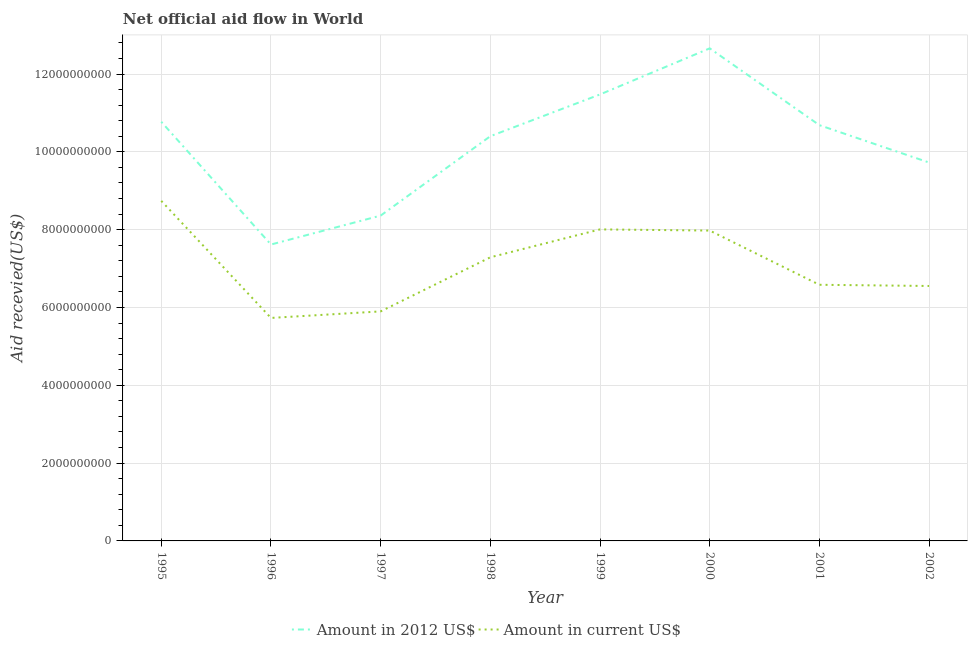How many different coloured lines are there?
Your answer should be compact. 2. Is the number of lines equal to the number of legend labels?
Provide a succinct answer. Yes. What is the amount of aid received(expressed in 2012 us$) in 2002?
Your answer should be very brief. 9.73e+09. Across all years, what is the maximum amount of aid received(expressed in us$)?
Make the answer very short. 8.74e+09. Across all years, what is the minimum amount of aid received(expressed in us$)?
Provide a short and direct response. 5.73e+09. In which year was the amount of aid received(expressed in us$) maximum?
Offer a very short reply. 1995. In which year was the amount of aid received(expressed in 2012 us$) minimum?
Provide a succinct answer. 1996. What is the total amount of aid received(expressed in 2012 us$) in the graph?
Make the answer very short. 8.17e+1. What is the difference between the amount of aid received(expressed in us$) in 1997 and that in 2001?
Provide a succinct answer. -6.84e+08. What is the difference between the amount of aid received(expressed in us$) in 2000 and the amount of aid received(expressed in 2012 us$) in 1996?
Offer a very short reply. 3.59e+08. What is the average amount of aid received(expressed in us$) per year?
Offer a very short reply. 7.10e+09. In the year 1995, what is the difference between the amount of aid received(expressed in us$) and amount of aid received(expressed in 2012 us$)?
Make the answer very short. -2.03e+09. What is the ratio of the amount of aid received(expressed in us$) in 1997 to that in 1998?
Ensure brevity in your answer.  0.81. Is the difference between the amount of aid received(expressed in us$) in 2000 and 2002 greater than the difference between the amount of aid received(expressed in 2012 us$) in 2000 and 2002?
Your answer should be compact. No. What is the difference between the highest and the second highest amount of aid received(expressed in 2012 us$)?
Your answer should be compact. 1.18e+09. What is the difference between the highest and the lowest amount of aid received(expressed in 2012 us$)?
Ensure brevity in your answer.  5.04e+09. In how many years, is the amount of aid received(expressed in us$) greater than the average amount of aid received(expressed in us$) taken over all years?
Your answer should be compact. 4. Does the amount of aid received(expressed in us$) monotonically increase over the years?
Give a very brief answer. No. Is the amount of aid received(expressed in us$) strictly less than the amount of aid received(expressed in 2012 us$) over the years?
Offer a terse response. Yes. What is the difference between two consecutive major ticks on the Y-axis?
Your answer should be compact. 2.00e+09. Are the values on the major ticks of Y-axis written in scientific E-notation?
Your answer should be very brief. No. Where does the legend appear in the graph?
Your response must be concise. Bottom center. How many legend labels are there?
Give a very brief answer. 2. What is the title of the graph?
Keep it short and to the point. Net official aid flow in World. Does "Nitrous oxide emissions" appear as one of the legend labels in the graph?
Offer a terse response. No. What is the label or title of the X-axis?
Keep it short and to the point. Year. What is the label or title of the Y-axis?
Ensure brevity in your answer.  Aid recevied(US$). What is the Aid recevied(US$) in Amount in 2012 US$ in 1995?
Provide a succinct answer. 1.08e+1. What is the Aid recevied(US$) of Amount in current US$ in 1995?
Provide a short and direct response. 8.74e+09. What is the Aid recevied(US$) of Amount in 2012 US$ in 1996?
Your answer should be compact. 7.62e+09. What is the Aid recevied(US$) in Amount in current US$ in 1996?
Your response must be concise. 5.73e+09. What is the Aid recevied(US$) of Amount in 2012 US$ in 1997?
Your answer should be very brief. 8.36e+09. What is the Aid recevied(US$) of Amount in current US$ in 1997?
Make the answer very short. 5.90e+09. What is the Aid recevied(US$) of Amount in 2012 US$ in 1998?
Give a very brief answer. 1.04e+1. What is the Aid recevied(US$) of Amount in current US$ in 1998?
Provide a short and direct response. 7.29e+09. What is the Aid recevied(US$) in Amount in 2012 US$ in 1999?
Your answer should be compact. 1.15e+1. What is the Aid recevied(US$) of Amount in current US$ in 1999?
Give a very brief answer. 8.01e+09. What is the Aid recevied(US$) of Amount in 2012 US$ in 2000?
Make the answer very short. 1.27e+1. What is the Aid recevied(US$) of Amount in current US$ in 2000?
Make the answer very short. 7.98e+09. What is the Aid recevied(US$) of Amount in 2012 US$ in 2001?
Your response must be concise. 1.07e+1. What is the Aid recevied(US$) of Amount in current US$ in 2001?
Provide a short and direct response. 6.58e+09. What is the Aid recevied(US$) in Amount in 2012 US$ in 2002?
Ensure brevity in your answer.  9.73e+09. What is the Aid recevied(US$) of Amount in current US$ in 2002?
Make the answer very short. 6.55e+09. Across all years, what is the maximum Aid recevied(US$) of Amount in 2012 US$?
Keep it short and to the point. 1.27e+1. Across all years, what is the maximum Aid recevied(US$) in Amount in current US$?
Keep it short and to the point. 8.74e+09. Across all years, what is the minimum Aid recevied(US$) of Amount in 2012 US$?
Your answer should be compact. 7.62e+09. Across all years, what is the minimum Aid recevied(US$) in Amount in current US$?
Provide a short and direct response. 5.73e+09. What is the total Aid recevied(US$) of Amount in 2012 US$ in the graph?
Your answer should be compact. 8.17e+1. What is the total Aid recevied(US$) in Amount in current US$ in the graph?
Keep it short and to the point. 5.68e+1. What is the difference between the Aid recevied(US$) in Amount in 2012 US$ in 1995 and that in 1996?
Your answer should be very brief. 3.16e+09. What is the difference between the Aid recevied(US$) of Amount in current US$ in 1995 and that in 1996?
Offer a very short reply. 3.01e+09. What is the difference between the Aid recevied(US$) of Amount in 2012 US$ in 1995 and that in 1997?
Offer a terse response. 2.41e+09. What is the difference between the Aid recevied(US$) in Amount in current US$ in 1995 and that in 1997?
Offer a terse response. 2.84e+09. What is the difference between the Aid recevied(US$) of Amount in 2012 US$ in 1995 and that in 1998?
Offer a very short reply. 3.71e+08. What is the difference between the Aid recevied(US$) in Amount in current US$ in 1995 and that in 1998?
Your answer should be very brief. 1.45e+09. What is the difference between the Aid recevied(US$) of Amount in 2012 US$ in 1995 and that in 1999?
Offer a very short reply. -7.02e+08. What is the difference between the Aid recevied(US$) in Amount in current US$ in 1995 and that in 1999?
Provide a succinct answer. 7.33e+08. What is the difference between the Aid recevied(US$) in Amount in 2012 US$ in 1995 and that in 2000?
Ensure brevity in your answer.  -1.89e+09. What is the difference between the Aid recevied(US$) of Amount in current US$ in 1995 and that in 2000?
Provide a succinct answer. 7.63e+08. What is the difference between the Aid recevied(US$) in Amount in 2012 US$ in 1995 and that in 2001?
Keep it short and to the point. 8.75e+07. What is the difference between the Aid recevied(US$) in Amount in current US$ in 1995 and that in 2001?
Ensure brevity in your answer.  2.16e+09. What is the difference between the Aid recevied(US$) of Amount in 2012 US$ in 1995 and that in 2002?
Your answer should be compact. 1.05e+09. What is the difference between the Aid recevied(US$) in Amount in current US$ in 1995 and that in 2002?
Your answer should be compact. 2.19e+09. What is the difference between the Aid recevied(US$) in Amount in 2012 US$ in 1996 and that in 1997?
Offer a terse response. -7.43e+08. What is the difference between the Aid recevied(US$) in Amount in current US$ in 1996 and that in 1997?
Your answer should be very brief. -1.68e+08. What is the difference between the Aid recevied(US$) in Amount in 2012 US$ in 1996 and that in 1998?
Provide a succinct answer. -2.78e+09. What is the difference between the Aid recevied(US$) of Amount in current US$ in 1996 and that in 1998?
Your answer should be compact. -1.56e+09. What is the difference between the Aid recevied(US$) in Amount in 2012 US$ in 1996 and that in 1999?
Give a very brief answer. -3.86e+09. What is the difference between the Aid recevied(US$) of Amount in current US$ in 1996 and that in 1999?
Your answer should be very brief. -2.28e+09. What is the difference between the Aid recevied(US$) in Amount in 2012 US$ in 1996 and that in 2000?
Provide a short and direct response. -5.04e+09. What is the difference between the Aid recevied(US$) of Amount in current US$ in 1996 and that in 2000?
Your answer should be compact. -2.25e+09. What is the difference between the Aid recevied(US$) in Amount in 2012 US$ in 1996 and that in 2001?
Offer a terse response. -3.07e+09. What is the difference between the Aid recevied(US$) of Amount in current US$ in 1996 and that in 2001?
Your answer should be compact. -8.52e+08. What is the difference between the Aid recevied(US$) of Amount in 2012 US$ in 1996 and that in 2002?
Offer a very short reply. -2.11e+09. What is the difference between the Aid recevied(US$) in Amount in current US$ in 1996 and that in 2002?
Offer a very short reply. -8.21e+08. What is the difference between the Aid recevied(US$) in Amount in 2012 US$ in 1997 and that in 1998?
Give a very brief answer. -2.04e+09. What is the difference between the Aid recevied(US$) of Amount in current US$ in 1997 and that in 1998?
Your answer should be compact. -1.39e+09. What is the difference between the Aid recevied(US$) of Amount in 2012 US$ in 1997 and that in 1999?
Make the answer very short. -3.11e+09. What is the difference between the Aid recevied(US$) in Amount in current US$ in 1997 and that in 1999?
Your answer should be very brief. -2.11e+09. What is the difference between the Aid recevied(US$) of Amount in 2012 US$ in 1997 and that in 2000?
Your answer should be compact. -4.30e+09. What is the difference between the Aid recevied(US$) of Amount in current US$ in 1997 and that in 2000?
Give a very brief answer. -2.08e+09. What is the difference between the Aid recevied(US$) of Amount in 2012 US$ in 1997 and that in 2001?
Keep it short and to the point. -2.32e+09. What is the difference between the Aid recevied(US$) of Amount in current US$ in 1997 and that in 2001?
Give a very brief answer. -6.84e+08. What is the difference between the Aid recevied(US$) of Amount in 2012 US$ in 1997 and that in 2002?
Your response must be concise. -1.36e+09. What is the difference between the Aid recevied(US$) of Amount in current US$ in 1997 and that in 2002?
Offer a very short reply. -6.53e+08. What is the difference between the Aid recevied(US$) in Amount in 2012 US$ in 1998 and that in 1999?
Your answer should be compact. -1.07e+09. What is the difference between the Aid recevied(US$) of Amount in current US$ in 1998 and that in 1999?
Your response must be concise. -7.18e+08. What is the difference between the Aid recevied(US$) of Amount in 2012 US$ in 1998 and that in 2000?
Your answer should be very brief. -2.26e+09. What is the difference between the Aid recevied(US$) of Amount in current US$ in 1998 and that in 2000?
Offer a very short reply. -6.87e+08. What is the difference between the Aid recevied(US$) of Amount in 2012 US$ in 1998 and that in 2001?
Ensure brevity in your answer.  -2.84e+08. What is the difference between the Aid recevied(US$) of Amount in current US$ in 1998 and that in 2001?
Provide a succinct answer. 7.06e+08. What is the difference between the Aid recevied(US$) of Amount in 2012 US$ in 1998 and that in 2002?
Your response must be concise. 6.77e+08. What is the difference between the Aid recevied(US$) of Amount in current US$ in 1998 and that in 2002?
Your response must be concise. 7.37e+08. What is the difference between the Aid recevied(US$) of Amount in 2012 US$ in 1999 and that in 2000?
Your response must be concise. -1.18e+09. What is the difference between the Aid recevied(US$) of Amount in current US$ in 1999 and that in 2000?
Keep it short and to the point. 3.04e+07. What is the difference between the Aid recevied(US$) of Amount in 2012 US$ in 1999 and that in 2001?
Give a very brief answer. 7.90e+08. What is the difference between the Aid recevied(US$) of Amount in current US$ in 1999 and that in 2001?
Keep it short and to the point. 1.42e+09. What is the difference between the Aid recevied(US$) of Amount in 2012 US$ in 1999 and that in 2002?
Provide a succinct answer. 1.75e+09. What is the difference between the Aid recevied(US$) of Amount in current US$ in 1999 and that in 2002?
Provide a succinct answer. 1.45e+09. What is the difference between the Aid recevied(US$) of Amount in 2012 US$ in 2000 and that in 2001?
Your answer should be compact. 1.97e+09. What is the difference between the Aid recevied(US$) in Amount in current US$ in 2000 and that in 2001?
Your answer should be very brief. 1.39e+09. What is the difference between the Aid recevied(US$) in Amount in 2012 US$ in 2000 and that in 2002?
Offer a very short reply. 2.93e+09. What is the difference between the Aid recevied(US$) of Amount in current US$ in 2000 and that in 2002?
Offer a very short reply. 1.42e+09. What is the difference between the Aid recevied(US$) of Amount in 2012 US$ in 2001 and that in 2002?
Ensure brevity in your answer.  9.60e+08. What is the difference between the Aid recevied(US$) of Amount in current US$ in 2001 and that in 2002?
Give a very brief answer. 3.09e+07. What is the difference between the Aid recevied(US$) in Amount in 2012 US$ in 1995 and the Aid recevied(US$) in Amount in current US$ in 1996?
Offer a very short reply. 5.04e+09. What is the difference between the Aid recevied(US$) of Amount in 2012 US$ in 1995 and the Aid recevied(US$) of Amount in current US$ in 1997?
Keep it short and to the point. 4.87e+09. What is the difference between the Aid recevied(US$) in Amount in 2012 US$ in 1995 and the Aid recevied(US$) in Amount in current US$ in 1998?
Give a very brief answer. 3.48e+09. What is the difference between the Aid recevied(US$) of Amount in 2012 US$ in 1995 and the Aid recevied(US$) of Amount in current US$ in 1999?
Your answer should be compact. 2.77e+09. What is the difference between the Aid recevied(US$) of Amount in 2012 US$ in 1995 and the Aid recevied(US$) of Amount in current US$ in 2000?
Keep it short and to the point. 2.80e+09. What is the difference between the Aid recevied(US$) of Amount in 2012 US$ in 1995 and the Aid recevied(US$) of Amount in current US$ in 2001?
Offer a terse response. 4.19e+09. What is the difference between the Aid recevied(US$) of Amount in 2012 US$ in 1995 and the Aid recevied(US$) of Amount in current US$ in 2002?
Your response must be concise. 4.22e+09. What is the difference between the Aid recevied(US$) in Amount in 2012 US$ in 1996 and the Aid recevied(US$) in Amount in current US$ in 1997?
Your response must be concise. 1.72e+09. What is the difference between the Aid recevied(US$) in Amount in 2012 US$ in 1996 and the Aid recevied(US$) in Amount in current US$ in 1998?
Your response must be concise. 3.29e+08. What is the difference between the Aid recevied(US$) of Amount in 2012 US$ in 1996 and the Aid recevied(US$) of Amount in current US$ in 1999?
Keep it short and to the point. -3.89e+08. What is the difference between the Aid recevied(US$) of Amount in 2012 US$ in 1996 and the Aid recevied(US$) of Amount in current US$ in 2000?
Offer a very short reply. -3.59e+08. What is the difference between the Aid recevied(US$) of Amount in 2012 US$ in 1996 and the Aid recevied(US$) of Amount in current US$ in 2001?
Your answer should be compact. 1.04e+09. What is the difference between the Aid recevied(US$) in Amount in 2012 US$ in 1996 and the Aid recevied(US$) in Amount in current US$ in 2002?
Ensure brevity in your answer.  1.07e+09. What is the difference between the Aid recevied(US$) of Amount in 2012 US$ in 1997 and the Aid recevied(US$) of Amount in current US$ in 1998?
Keep it short and to the point. 1.07e+09. What is the difference between the Aid recevied(US$) in Amount in 2012 US$ in 1997 and the Aid recevied(US$) in Amount in current US$ in 1999?
Give a very brief answer. 3.54e+08. What is the difference between the Aid recevied(US$) of Amount in 2012 US$ in 1997 and the Aid recevied(US$) of Amount in current US$ in 2000?
Provide a short and direct response. 3.85e+08. What is the difference between the Aid recevied(US$) of Amount in 2012 US$ in 1997 and the Aid recevied(US$) of Amount in current US$ in 2001?
Make the answer very short. 1.78e+09. What is the difference between the Aid recevied(US$) in Amount in 2012 US$ in 1997 and the Aid recevied(US$) in Amount in current US$ in 2002?
Provide a succinct answer. 1.81e+09. What is the difference between the Aid recevied(US$) in Amount in 2012 US$ in 1998 and the Aid recevied(US$) in Amount in current US$ in 1999?
Ensure brevity in your answer.  2.39e+09. What is the difference between the Aid recevied(US$) of Amount in 2012 US$ in 1998 and the Aid recevied(US$) of Amount in current US$ in 2000?
Your response must be concise. 2.43e+09. What is the difference between the Aid recevied(US$) in Amount in 2012 US$ in 1998 and the Aid recevied(US$) in Amount in current US$ in 2001?
Offer a very short reply. 3.82e+09. What is the difference between the Aid recevied(US$) of Amount in 2012 US$ in 1998 and the Aid recevied(US$) of Amount in current US$ in 2002?
Your answer should be compact. 3.85e+09. What is the difference between the Aid recevied(US$) of Amount in 2012 US$ in 1999 and the Aid recevied(US$) of Amount in current US$ in 2000?
Ensure brevity in your answer.  3.50e+09. What is the difference between the Aid recevied(US$) in Amount in 2012 US$ in 1999 and the Aid recevied(US$) in Amount in current US$ in 2001?
Your response must be concise. 4.89e+09. What is the difference between the Aid recevied(US$) of Amount in 2012 US$ in 1999 and the Aid recevied(US$) of Amount in current US$ in 2002?
Give a very brief answer. 4.92e+09. What is the difference between the Aid recevied(US$) in Amount in 2012 US$ in 2000 and the Aid recevied(US$) in Amount in current US$ in 2001?
Provide a succinct answer. 6.08e+09. What is the difference between the Aid recevied(US$) of Amount in 2012 US$ in 2000 and the Aid recevied(US$) of Amount in current US$ in 2002?
Offer a very short reply. 6.11e+09. What is the difference between the Aid recevied(US$) in Amount in 2012 US$ in 2001 and the Aid recevied(US$) in Amount in current US$ in 2002?
Make the answer very short. 4.13e+09. What is the average Aid recevied(US$) of Amount in 2012 US$ per year?
Provide a succinct answer. 1.02e+1. What is the average Aid recevied(US$) in Amount in current US$ per year?
Your answer should be compact. 7.10e+09. In the year 1995, what is the difference between the Aid recevied(US$) of Amount in 2012 US$ and Aid recevied(US$) of Amount in current US$?
Your response must be concise. 2.03e+09. In the year 1996, what is the difference between the Aid recevied(US$) of Amount in 2012 US$ and Aid recevied(US$) of Amount in current US$?
Your answer should be compact. 1.89e+09. In the year 1997, what is the difference between the Aid recevied(US$) in Amount in 2012 US$ and Aid recevied(US$) in Amount in current US$?
Keep it short and to the point. 2.46e+09. In the year 1998, what is the difference between the Aid recevied(US$) in Amount in 2012 US$ and Aid recevied(US$) in Amount in current US$?
Make the answer very short. 3.11e+09. In the year 1999, what is the difference between the Aid recevied(US$) of Amount in 2012 US$ and Aid recevied(US$) of Amount in current US$?
Provide a succinct answer. 3.47e+09. In the year 2000, what is the difference between the Aid recevied(US$) in Amount in 2012 US$ and Aid recevied(US$) in Amount in current US$?
Offer a terse response. 4.68e+09. In the year 2001, what is the difference between the Aid recevied(US$) in Amount in 2012 US$ and Aid recevied(US$) in Amount in current US$?
Offer a terse response. 4.10e+09. In the year 2002, what is the difference between the Aid recevied(US$) in Amount in 2012 US$ and Aid recevied(US$) in Amount in current US$?
Ensure brevity in your answer.  3.17e+09. What is the ratio of the Aid recevied(US$) in Amount in 2012 US$ in 1995 to that in 1996?
Offer a terse response. 1.41. What is the ratio of the Aid recevied(US$) of Amount in current US$ in 1995 to that in 1996?
Ensure brevity in your answer.  1.52. What is the ratio of the Aid recevied(US$) in Amount in 2012 US$ in 1995 to that in 1997?
Provide a short and direct response. 1.29. What is the ratio of the Aid recevied(US$) in Amount in current US$ in 1995 to that in 1997?
Offer a very short reply. 1.48. What is the ratio of the Aid recevied(US$) in Amount in 2012 US$ in 1995 to that in 1998?
Provide a succinct answer. 1.04. What is the ratio of the Aid recevied(US$) in Amount in current US$ in 1995 to that in 1998?
Your answer should be compact. 1.2. What is the ratio of the Aid recevied(US$) of Amount in 2012 US$ in 1995 to that in 1999?
Give a very brief answer. 0.94. What is the ratio of the Aid recevied(US$) of Amount in current US$ in 1995 to that in 1999?
Ensure brevity in your answer.  1.09. What is the ratio of the Aid recevied(US$) in Amount in 2012 US$ in 1995 to that in 2000?
Make the answer very short. 0.85. What is the ratio of the Aid recevied(US$) in Amount in current US$ in 1995 to that in 2000?
Keep it short and to the point. 1.1. What is the ratio of the Aid recevied(US$) in Amount in 2012 US$ in 1995 to that in 2001?
Your response must be concise. 1.01. What is the ratio of the Aid recevied(US$) of Amount in current US$ in 1995 to that in 2001?
Make the answer very short. 1.33. What is the ratio of the Aid recevied(US$) of Amount in 2012 US$ in 1995 to that in 2002?
Offer a terse response. 1.11. What is the ratio of the Aid recevied(US$) of Amount in current US$ in 1995 to that in 2002?
Offer a very short reply. 1.33. What is the ratio of the Aid recevied(US$) in Amount in 2012 US$ in 1996 to that in 1997?
Ensure brevity in your answer.  0.91. What is the ratio of the Aid recevied(US$) in Amount in current US$ in 1996 to that in 1997?
Give a very brief answer. 0.97. What is the ratio of the Aid recevied(US$) of Amount in 2012 US$ in 1996 to that in 1998?
Give a very brief answer. 0.73. What is the ratio of the Aid recevied(US$) in Amount in current US$ in 1996 to that in 1998?
Ensure brevity in your answer.  0.79. What is the ratio of the Aid recevied(US$) of Amount in 2012 US$ in 1996 to that in 1999?
Your answer should be very brief. 0.66. What is the ratio of the Aid recevied(US$) of Amount in current US$ in 1996 to that in 1999?
Your response must be concise. 0.72. What is the ratio of the Aid recevied(US$) of Amount in 2012 US$ in 1996 to that in 2000?
Offer a terse response. 0.6. What is the ratio of the Aid recevied(US$) in Amount in current US$ in 1996 to that in 2000?
Ensure brevity in your answer.  0.72. What is the ratio of the Aid recevied(US$) of Amount in 2012 US$ in 1996 to that in 2001?
Your response must be concise. 0.71. What is the ratio of the Aid recevied(US$) of Amount in current US$ in 1996 to that in 2001?
Make the answer very short. 0.87. What is the ratio of the Aid recevied(US$) in Amount in 2012 US$ in 1996 to that in 2002?
Your response must be concise. 0.78. What is the ratio of the Aid recevied(US$) in Amount in current US$ in 1996 to that in 2002?
Provide a short and direct response. 0.87. What is the ratio of the Aid recevied(US$) in Amount in 2012 US$ in 1997 to that in 1998?
Provide a short and direct response. 0.8. What is the ratio of the Aid recevied(US$) in Amount in current US$ in 1997 to that in 1998?
Keep it short and to the point. 0.81. What is the ratio of the Aid recevied(US$) in Amount in 2012 US$ in 1997 to that in 1999?
Your answer should be very brief. 0.73. What is the ratio of the Aid recevied(US$) of Amount in current US$ in 1997 to that in 1999?
Provide a succinct answer. 0.74. What is the ratio of the Aid recevied(US$) in Amount in 2012 US$ in 1997 to that in 2000?
Your response must be concise. 0.66. What is the ratio of the Aid recevied(US$) of Amount in current US$ in 1997 to that in 2000?
Give a very brief answer. 0.74. What is the ratio of the Aid recevied(US$) in Amount in 2012 US$ in 1997 to that in 2001?
Offer a terse response. 0.78. What is the ratio of the Aid recevied(US$) of Amount in current US$ in 1997 to that in 2001?
Your response must be concise. 0.9. What is the ratio of the Aid recevied(US$) in Amount in 2012 US$ in 1997 to that in 2002?
Offer a terse response. 0.86. What is the ratio of the Aid recevied(US$) in Amount in current US$ in 1997 to that in 2002?
Give a very brief answer. 0.9. What is the ratio of the Aid recevied(US$) of Amount in 2012 US$ in 1998 to that in 1999?
Give a very brief answer. 0.91. What is the ratio of the Aid recevied(US$) of Amount in current US$ in 1998 to that in 1999?
Your answer should be compact. 0.91. What is the ratio of the Aid recevied(US$) in Amount in 2012 US$ in 1998 to that in 2000?
Give a very brief answer. 0.82. What is the ratio of the Aid recevied(US$) in Amount in current US$ in 1998 to that in 2000?
Your answer should be compact. 0.91. What is the ratio of the Aid recevied(US$) in Amount in 2012 US$ in 1998 to that in 2001?
Your answer should be compact. 0.97. What is the ratio of the Aid recevied(US$) in Amount in current US$ in 1998 to that in 2001?
Provide a short and direct response. 1.11. What is the ratio of the Aid recevied(US$) of Amount in 2012 US$ in 1998 to that in 2002?
Offer a terse response. 1.07. What is the ratio of the Aid recevied(US$) in Amount in current US$ in 1998 to that in 2002?
Provide a short and direct response. 1.11. What is the ratio of the Aid recevied(US$) in Amount in 2012 US$ in 1999 to that in 2000?
Offer a terse response. 0.91. What is the ratio of the Aid recevied(US$) of Amount in current US$ in 1999 to that in 2000?
Your answer should be compact. 1. What is the ratio of the Aid recevied(US$) in Amount in 2012 US$ in 1999 to that in 2001?
Your response must be concise. 1.07. What is the ratio of the Aid recevied(US$) of Amount in current US$ in 1999 to that in 2001?
Your response must be concise. 1.22. What is the ratio of the Aid recevied(US$) in Amount in 2012 US$ in 1999 to that in 2002?
Provide a short and direct response. 1.18. What is the ratio of the Aid recevied(US$) in Amount in current US$ in 1999 to that in 2002?
Offer a very short reply. 1.22. What is the ratio of the Aid recevied(US$) in Amount in 2012 US$ in 2000 to that in 2001?
Ensure brevity in your answer.  1.18. What is the ratio of the Aid recevied(US$) in Amount in current US$ in 2000 to that in 2001?
Provide a succinct answer. 1.21. What is the ratio of the Aid recevied(US$) of Amount in 2012 US$ in 2000 to that in 2002?
Make the answer very short. 1.3. What is the ratio of the Aid recevied(US$) of Amount in current US$ in 2000 to that in 2002?
Offer a terse response. 1.22. What is the ratio of the Aid recevied(US$) in Amount in 2012 US$ in 2001 to that in 2002?
Your answer should be very brief. 1.1. What is the ratio of the Aid recevied(US$) in Amount in current US$ in 2001 to that in 2002?
Offer a terse response. 1. What is the difference between the highest and the second highest Aid recevied(US$) in Amount in 2012 US$?
Offer a very short reply. 1.18e+09. What is the difference between the highest and the second highest Aid recevied(US$) of Amount in current US$?
Give a very brief answer. 7.33e+08. What is the difference between the highest and the lowest Aid recevied(US$) of Amount in 2012 US$?
Make the answer very short. 5.04e+09. What is the difference between the highest and the lowest Aid recevied(US$) in Amount in current US$?
Your answer should be very brief. 3.01e+09. 